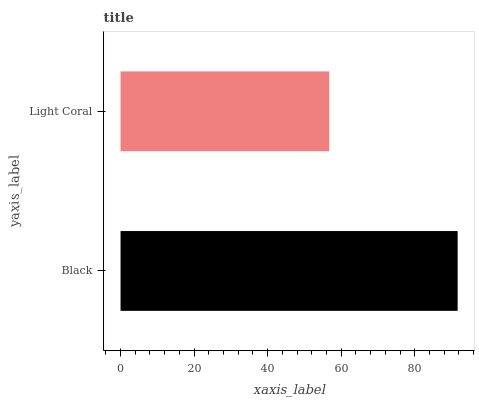Is Light Coral the minimum?
Answer yes or no. Yes. Is Black the maximum?
Answer yes or no. Yes. Is Light Coral the maximum?
Answer yes or no. No. Is Black greater than Light Coral?
Answer yes or no. Yes. Is Light Coral less than Black?
Answer yes or no. Yes. Is Light Coral greater than Black?
Answer yes or no. No. Is Black less than Light Coral?
Answer yes or no. No. Is Black the high median?
Answer yes or no. Yes. Is Light Coral the low median?
Answer yes or no. Yes. Is Light Coral the high median?
Answer yes or no. No. Is Black the low median?
Answer yes or no. No. 